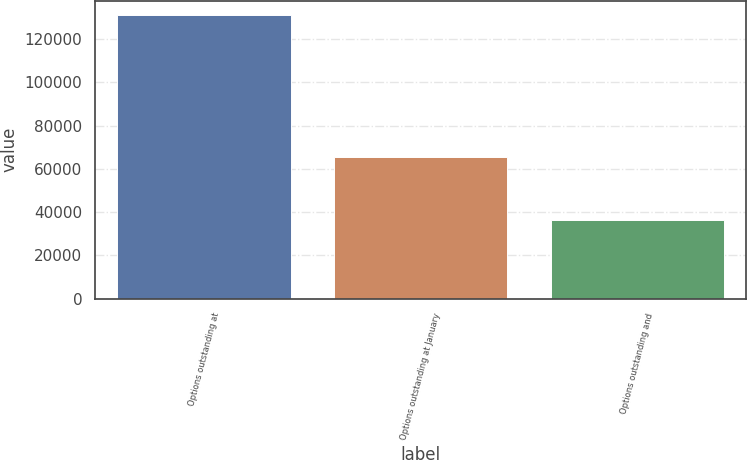<chart> <loc_0><loc_0><loc_500><loc_500><bar_chart><fcel>Options outstanding at<fcel>Options outstanding at January<fcel>Options outstanding and<nl><fcel>131219<fcel>65531<fcel>36438<nl></chart> 